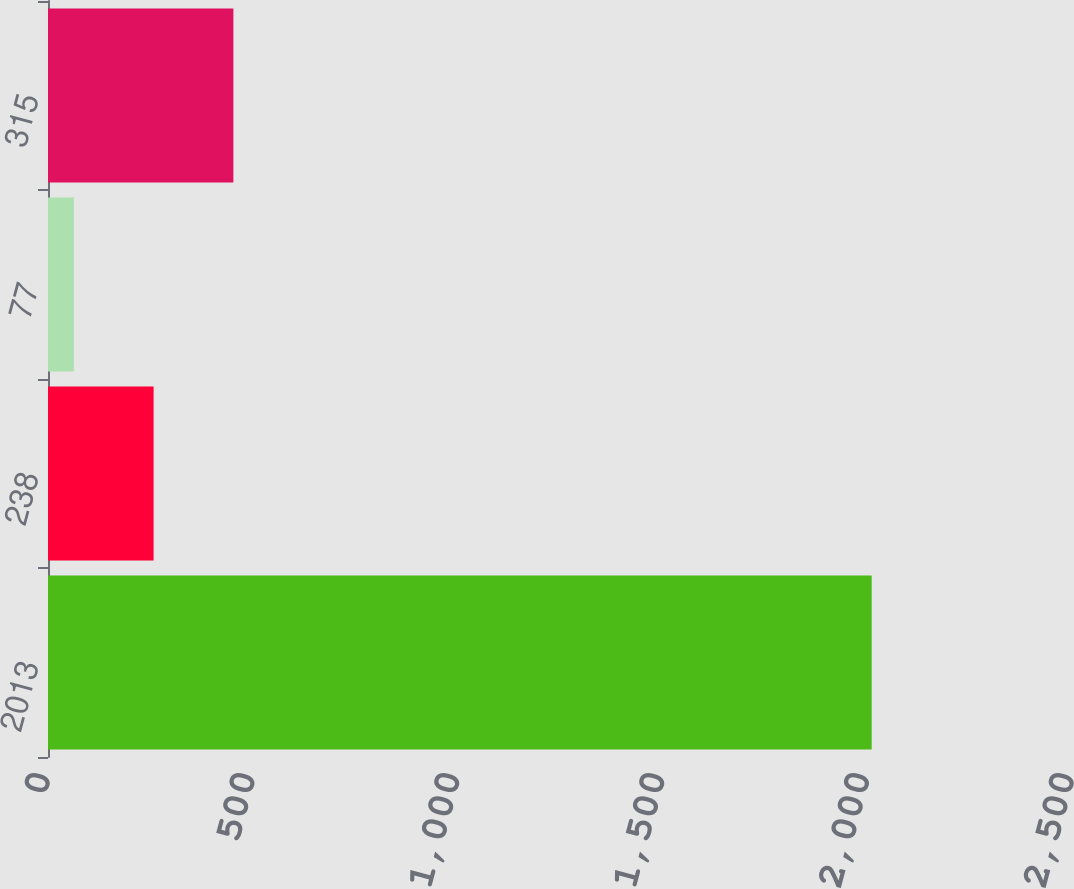Convert chart to OTSL. <chart><loc_0><loc_0><loc_500><loc_500><bar_chart><fcel>2013<fcel>238<fcel>77<fcel>315<nl><fcel>2011<fcel>257.8<fcel>63<fcel>452.6<nl></chart> 